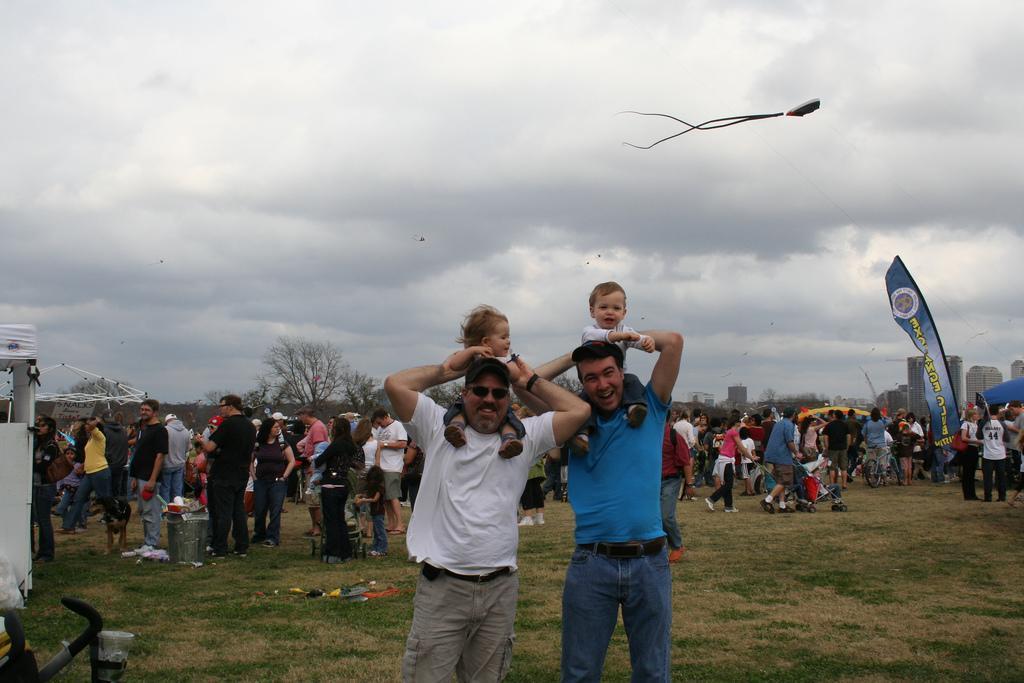How many flags are to the right fo the man in the blue shirt?
Give a very brief answer. 1. 